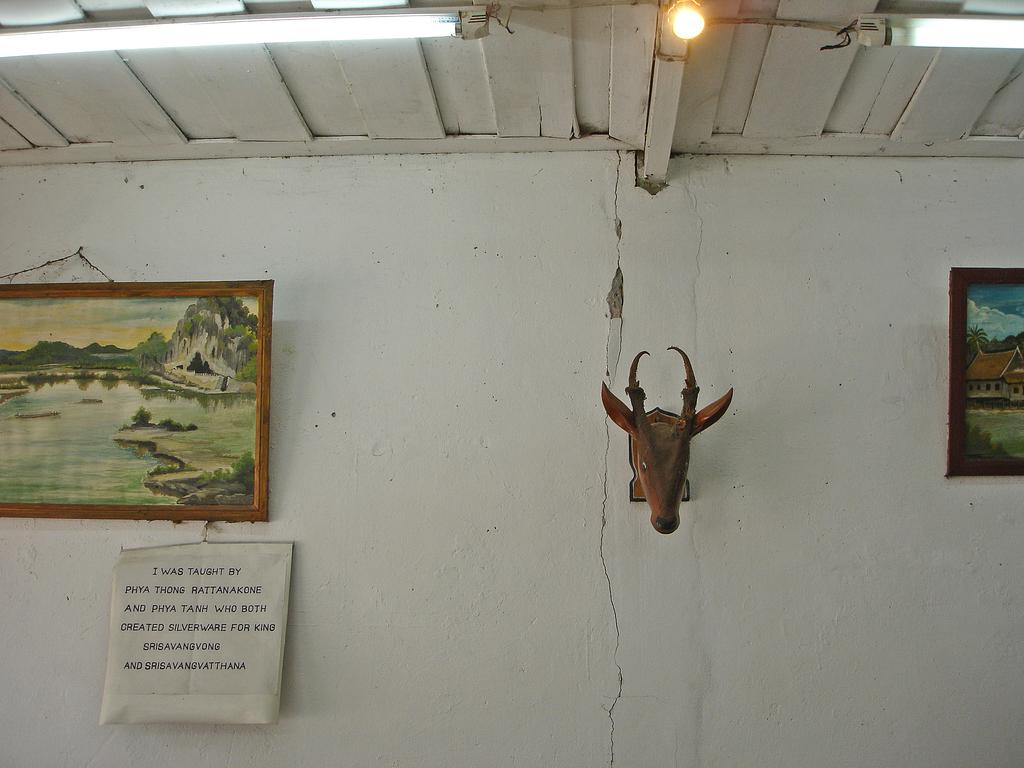What is the color of the wall in the image? The wall in the image is white. What objects are present on the wall? There are photo frames in the image. What type of object can be seen on the surface of the wall? There is a paper in the image. What can be seen providing illumination in the image? There are lights in the image. What type of cabbage is being harvested in the image? There is no cabbage present in the image; it features a white wall with photo frames, a paper, and lights. What time of day is depicted in the image? The time of day cannot be determined from the image, as there are no specific indicators of morning or any other time. 